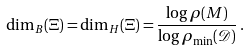<formula> <loc_0><loc_0><loc_500><loc_500>\dim _ { B } ( \Xi ) = \dim _ { H } ( \Xi ) = \frac { \log \rho ( M ) } { \log \rho _ { \min } ( \mathcal { D } ) } \, .</formula> 